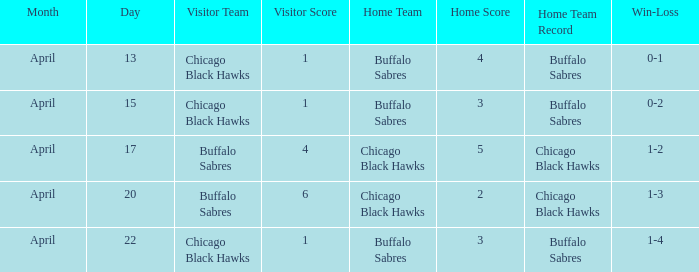Which Score has a Visitor of buffalo sabres and a Record of 1-3? 6–2. 